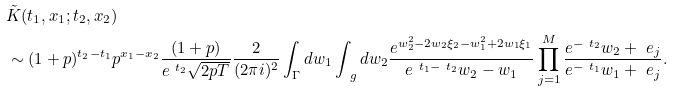<formula> <loc_0><loc_0><loc_500><loc_500>& \tilde { K } ( t _ { 1 } , x _ { 1 } ; t _ { 2 } , x _ { 2 } ) \\ & \sim ( 1 + p ) ^ { t _ { 2 } - t _ { 1 } } p ^ { x _ { 1 } - x _ { 2 } } \frac { ( 1 + p ) } { e ^ { \ t _ { 2 } } \sqrt { 2 p T } } \frac { 2 } { ( 2 \pi i ) ^ { 2 } } \int _ { \Gamma } d w _ { 1 } \int _ { \ g } d w _ { 2 } \frac { e ^ { w _ { 2 } ^ { 2 } - 2 w _ { 2 } \xi _ { 2 } - w _ { 1 } ^ { 2 } + 2 w _ { 1 } \xi _ { 1 } } } { e ^ { \ t _ { 1 } - \ t _ { 2 } } w _ { 2 } - w _ { 1 } } \prod _ { j = 1 } ^ { M } \frac { e ^ { - \ t _ { 2 } } w _ { 2 } + \ e _ { j } } { e ^ { - \ t _ { 1 } } w _ { 1 } + \ e _ { j } } .</formula> 